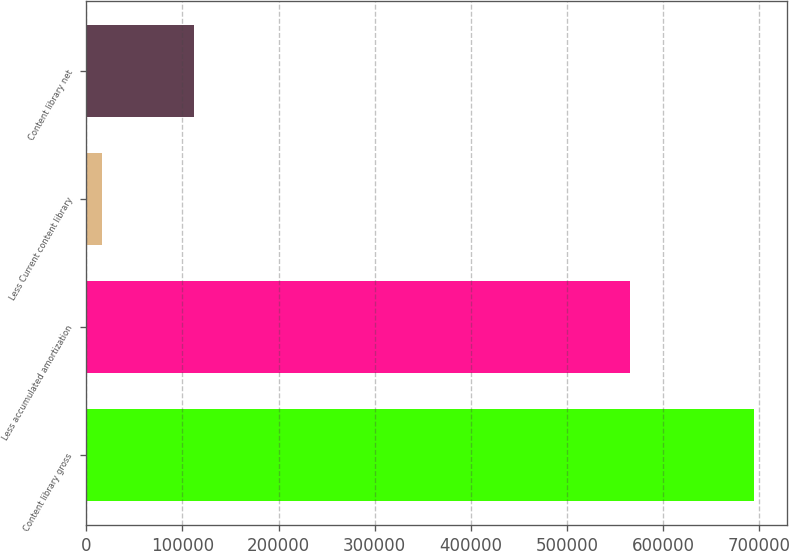Convert chart to OTSL. <chart><loc_0><loc_0><loc_500><loc_500><bar_chart><fcel>Content library gross<fcel>Less accumulated amortization<fcel>Less Current content library<fcel>Content library net<nl><fcel>694620<fcel>566249<fcel>16301<fcel>112070<nl></chart> 